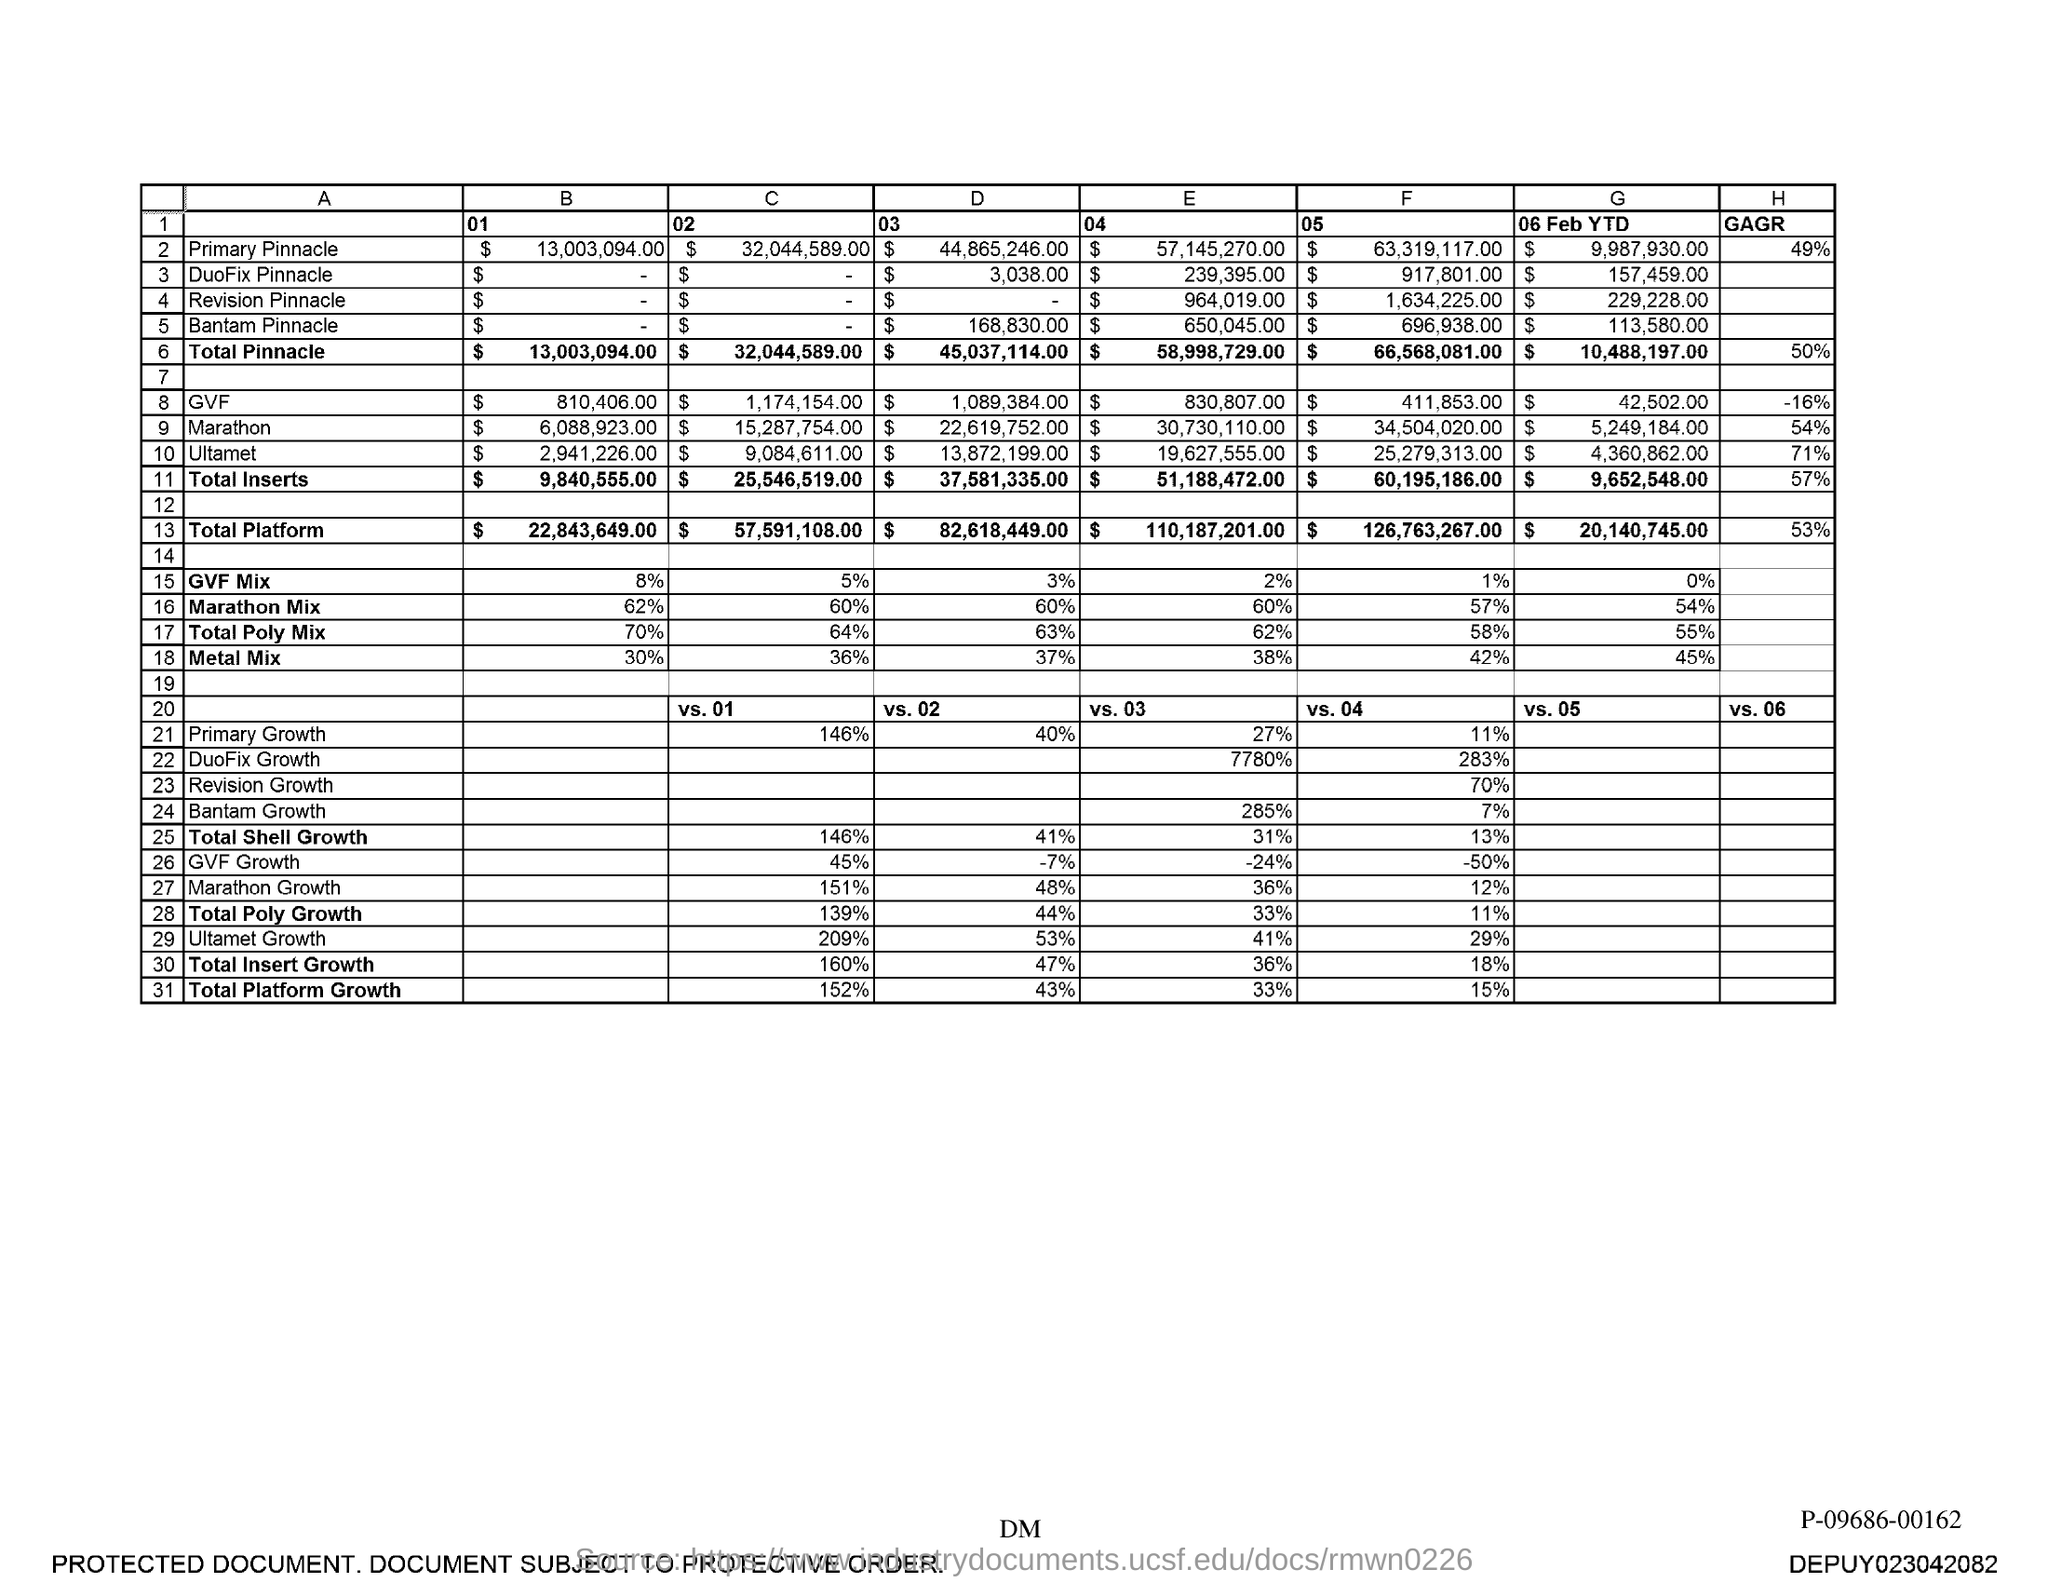What is the total Pinnacle value for column B?
Make the answer very short. $ 13,003,094.00. 